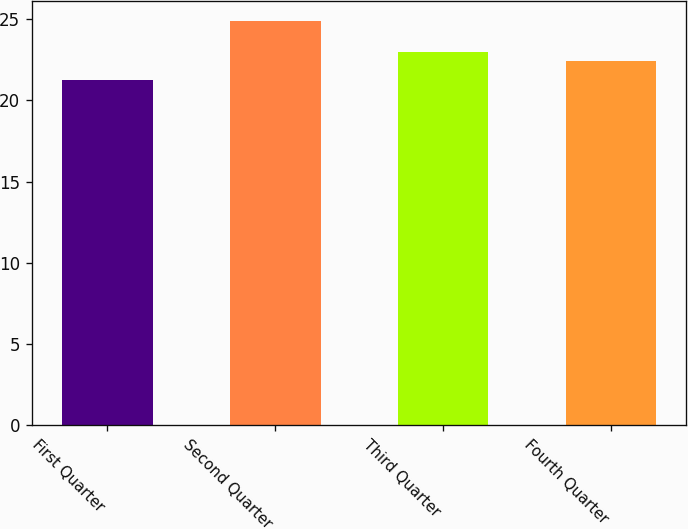Convert chart. <chart><loc_0><loc_0><loc_500><loc_500><bar_chart><fcel>First Quarter<fcel>Second Quarter<fcel>Third Quarter<fcel>Fourth Quarter<nl><fcel>21.23<fcel>24.9<fcel>22.99<fcel>22.45<nl></chart> 